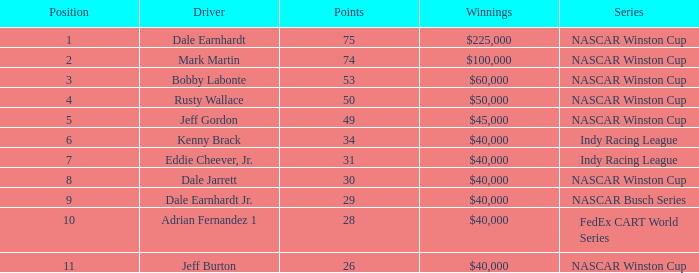Would you be able to parse every entry in this table? {'header': ['Position', 'Driver', 'Points', 'Winnings', 'Series'], 'rows': [['1', 'Dale Earnhardt', '75', '$225,000', 'NASCAR Winston Cup'], ['2', 'Mark Martin', '74', '$100,000', 'NASCAR Winston Cup'], ['3', 'Bobby Labonte', '53', '$60,000', 'NASCAR Winston Cup'], ['4', 'Rusty Wallace', '50', '$50,000', 'NASCAR Winston Cup'], ['5', 'Jeff Gordon', '49', '$45,000', 'NASCAR Winston Cup'], ['6', 'Kenny Brack', '34', '$40,000', 'Indy Racing League'], ['7', 'Eddie Cheever, Jr.', '31', '$40,000', 'Indy Racing League'], ['8', 'Dale Jarrett', '30', '$40,000', 'NASCAR Winston Cup'], ['9', 'Dale Earnhardt Jr.', '29', '$40,000', 'NASCAR Busch Series'], ['10', 'Adrian Fernandez 1', '28', '$40,000', 'FedEx CART World Series'], ['11', 'Jeff Burton', '26', '$40,000', 'NASCAR Winston Cup']]} Which place did the driver who secured $60,000 finish in? 3.0. 